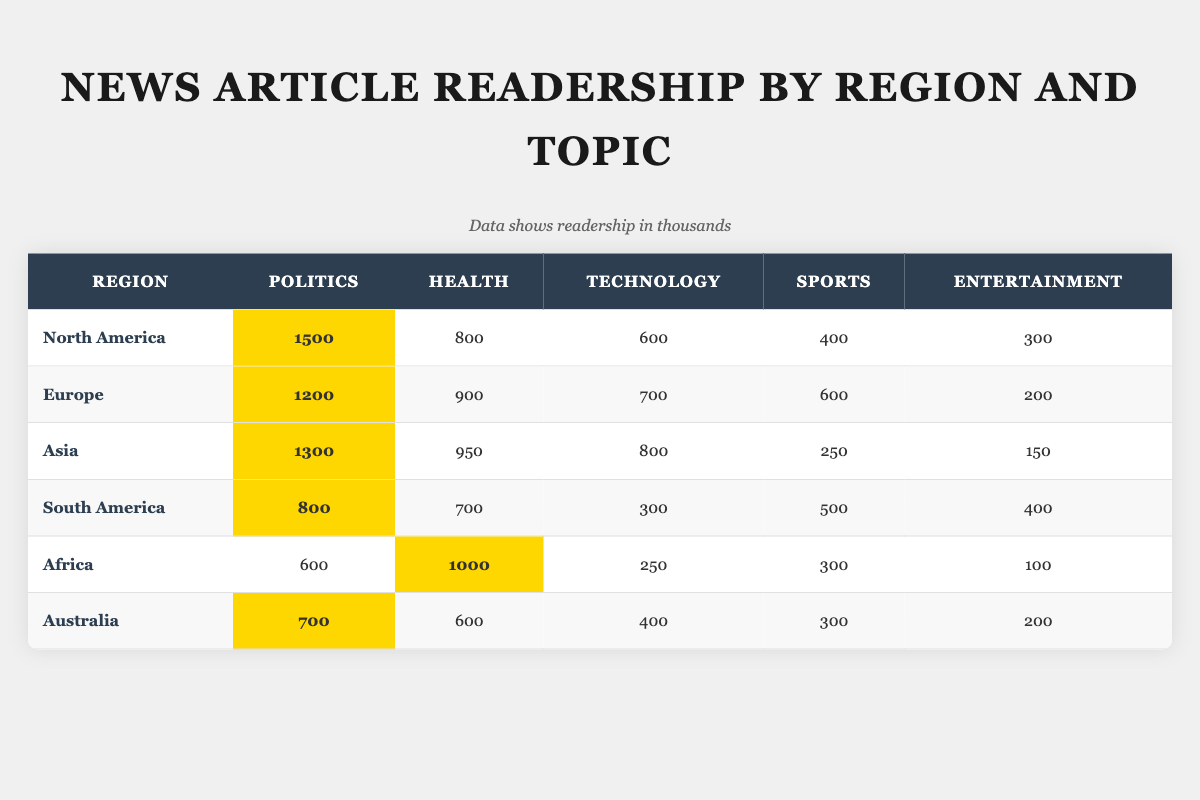What region has the highest readership in Politics? By inspecting the "Politics" column, North America shows the highest value of 1500.
Answer: North America Which region shows the least readership in Entertainment? Looking at the "Entertainment" column, Africa has the least value of 100.
Answer: Africa What is the total readership for Health articles in Asia and South America? The total for Asia is 950 and for South America is 700. Adding them together gives 950 + 700 = 1650.
Answer: 1650 Is the readership for Technology in Europe higher than that in Australia? In Europe, the readership for Technology is 700, while in Australia it is 400. Since 700 is greater than 400, the statement is true.
Answer: Yes Which two regions have the highest combined readership in Sports? The highest readership in Sports is 600 in Europe and 500 in South America. Adding these values gives 600 + 500 = 1100, which is the highest combined total from the table.
Answer: 1100 What is the average readership in Politics across all regions? The sum of the readership in Politics for all regions is 1500 (NA) + 1200 (EU) + 1300 (AS) + 800 (SA) + 600 (AF) + 700 (AU) = 5100. There are six regions, so the average is 5100 / 6 = 850.
Answer: 850 Which topic has the highest total readership across all regions? The total readership for each topic is calculated: Politics = 5100, Health = 4150, Technology = 3050, Sports = 2250, Entertainment = 1450. Politics has the highest total readership of 5100.
Answer: Politics Which region has a higher readership in Health: North America or Europe? North America has 800 in Health while Europe has 900. Since 900 is greater than 800, Europe has the higher readership in Health.
Answer: Europe 